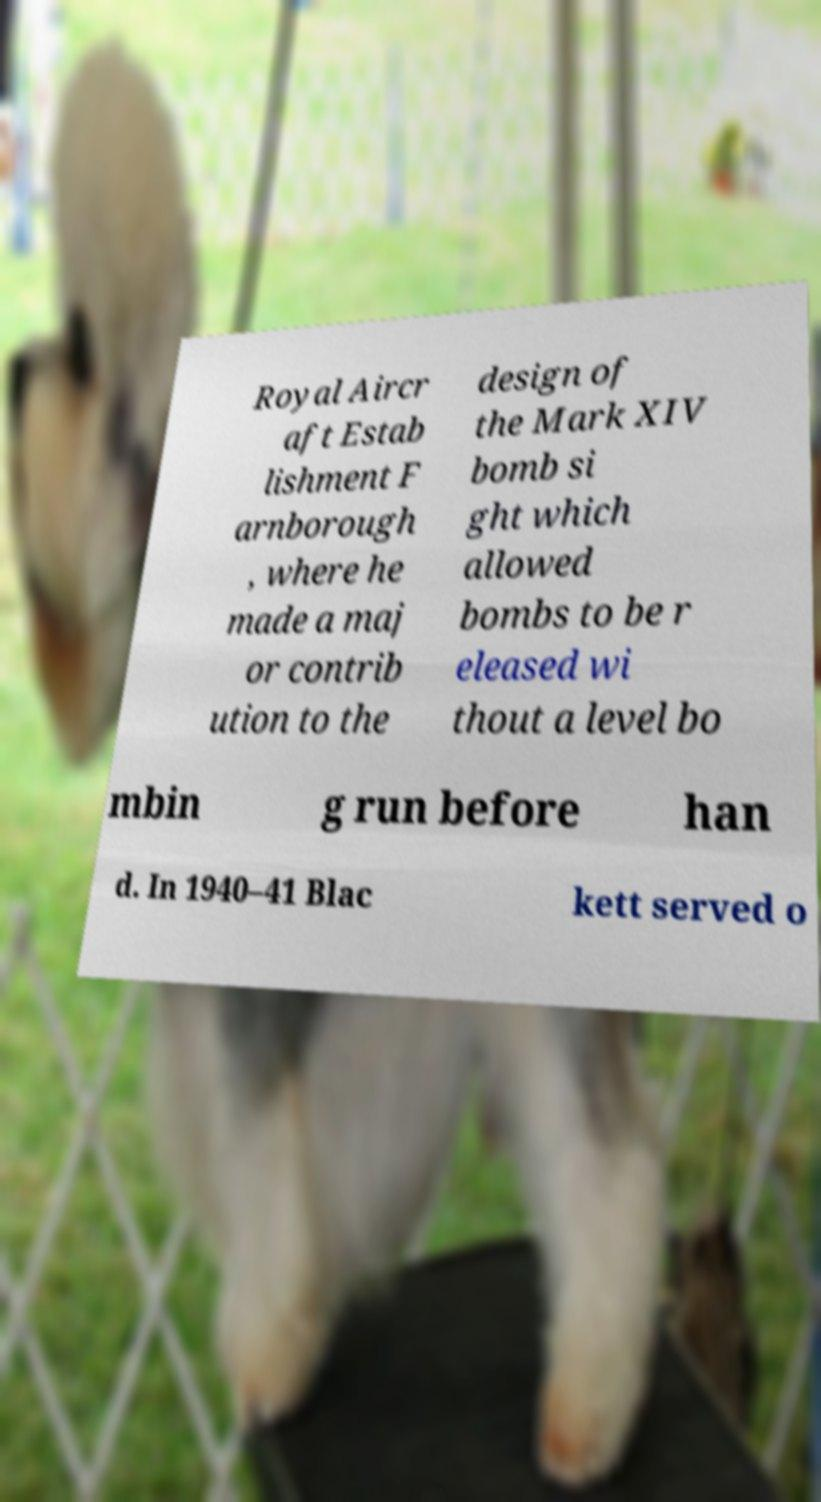Please read and relay the text visible in this image. What does it say? Royal Aircr aft Estab lishment F arnborough , where he made a maj or contrib ution to the design of the Mark XIV bomb si ght which allowed bombs to be r eleased wi thout a level bo mbin g run before han d. In 1940–41 Blac kett served o 